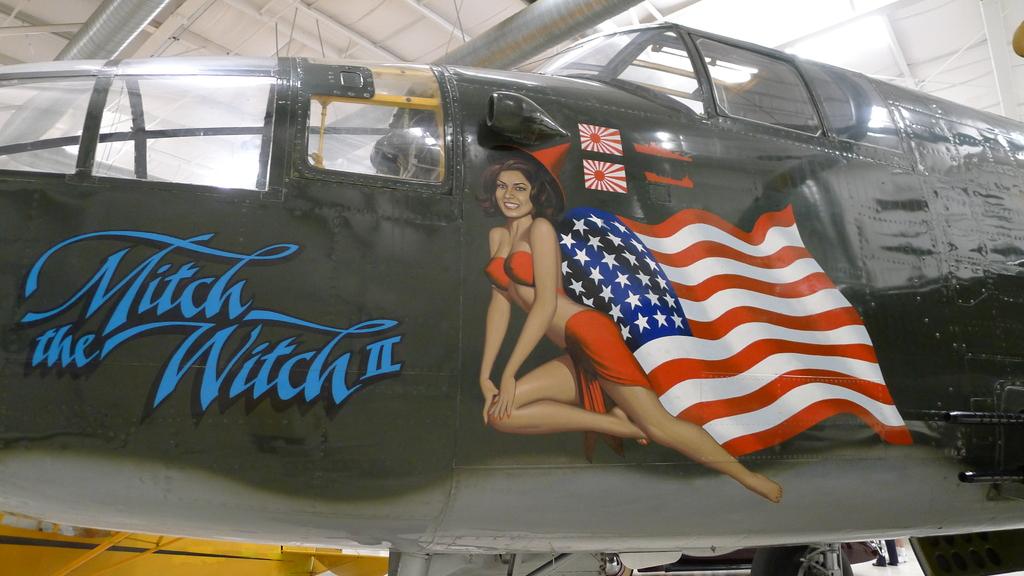Is this an old war plane?
Provide a succinct answer. Yes. Is that plane named mitch the witch?
Offer a terse response. Yes. 